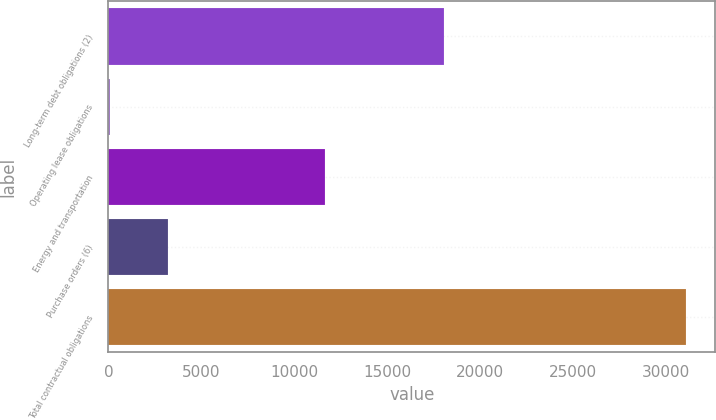Convert chart. <chart><loc_0><loc_0><loc_500><loc_500><bar_chart><fcel>Long-term debt obligations (2)<fcel>Operating lease obligations<fcel>Energy and transportation<fcel>Purchase orders (6)<fcel>Total contractual obligations<nl><fcel>18025.9<fcel>115.1<fcel>11640.9<fcel>3210.68<fcel>31070.9<nl></chart> 